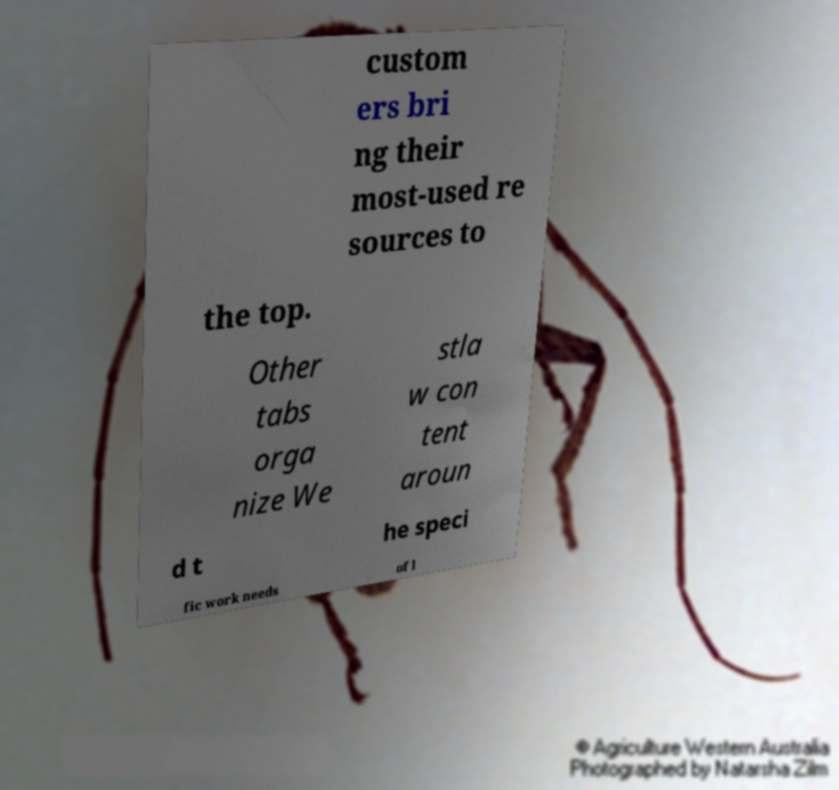Please read and relay the text visible in this image. What does it say? custom ers bri ng their most-used re sources to the top. Other tabs orga nize We stla w con tent aroun d t he speci fic work needs of l 